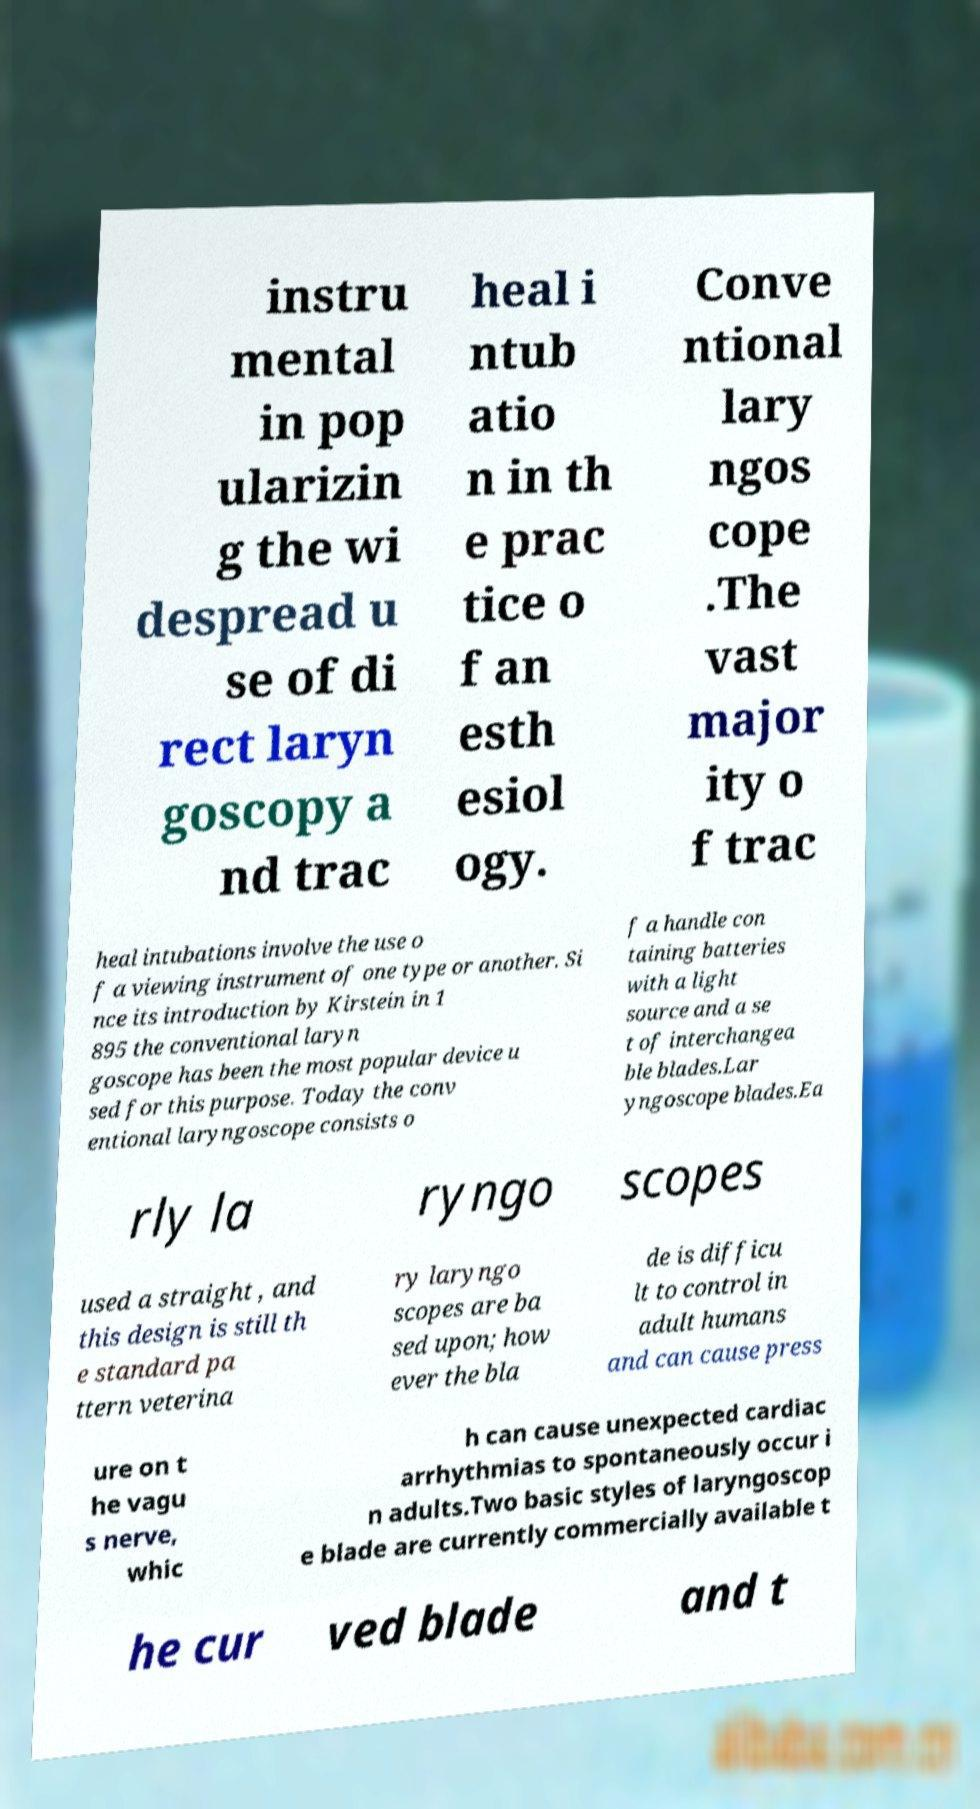Please identify and transcribe the text found in this image. instru mental in pop ularizin g the wi despread u se of di rect laryn goscopy a nd trac heal i ntub atio n in th e prac tice o f an esth esiol ogy. Conve ntional lary ngos cope .The vast major ity o f trac heal intubations involve the use o f a viewing instrument of one type or another. Si nce its introduction by Kirstein in 1 895 the conventional laryn goscope has been the most popular device u sed for this purpose. Today the conv entional laryngoscope consists o f a handle con taining batteries with a light source and a se t of interchangea ble blades.Lar yngoscope blades.Ea rly la ryngo scopes used a straight , and this design is still th e standard pa ttern veterina ry laryngo scopes are ba sed upon; how ever the bla de is difficu lt to control in adult humans and can cause press ure on t he vagu s nerve, whic h can cause unexpected cardiac arrhythmias to spontaneously occur i n adults.Two basic styles of laryngoscop e blade are currently commercially available t he cur ved blade and t 